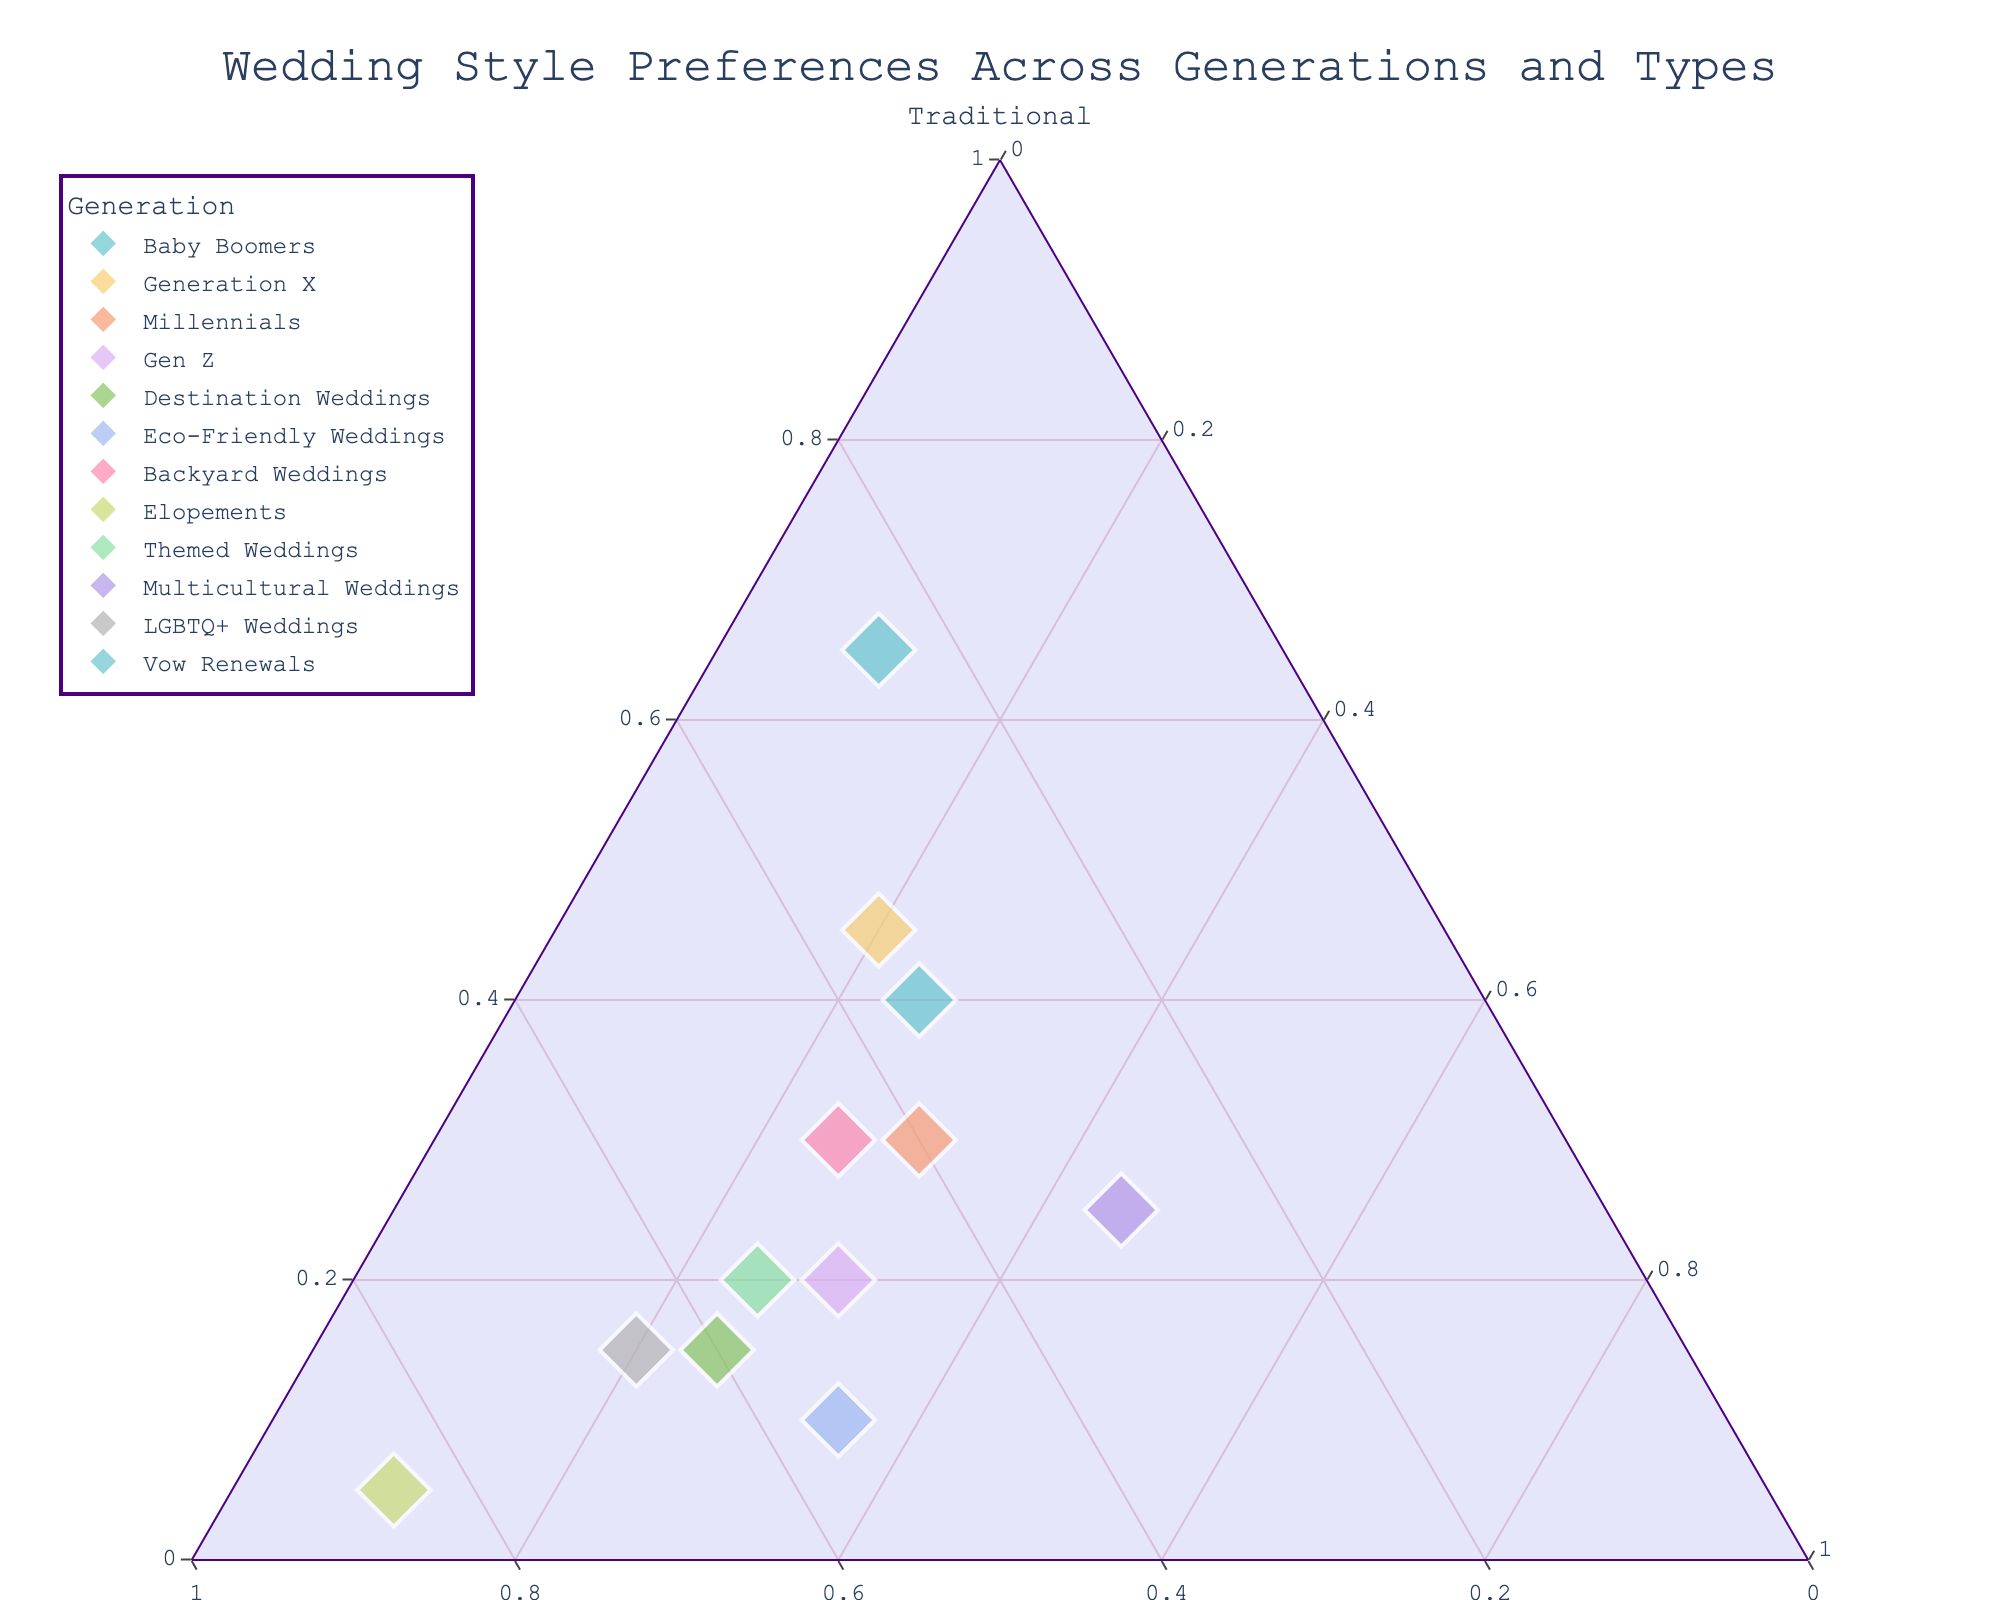Which generation has the highest preference for traditional weddings? The Baby Boomers segment has a data point positioned closest to the "Traditional" vertex of the triangle, indicating they have the highest percentage of preference for traditional weddings.
Answer: Baby Boomers Which type of wedding has the lowest preference for non-traditional weddings? The Elopements segment is closest to the "Non-Traditional" vertex, showing they have the highest non-traditional weddings preference and, therefore, the lowest percentage of traditional weddings preference.
Answer: Elopements How does the preference for fusion weddings compare between Millennials and Generation X? Millennials and Generation X both have their data points positioned equally distant from the 'Fusion' vertex; however, Millennials are closer, indicating that Millennials have a higher preference for fusion weddings than Generation X.
Answer: Millennials Which type of wedding shows the highest preference for non-traditional styles? The Elopements have their data point located closest to the "Non-Traditional" vertex, showing the highest preference for non-traditional weddings.
Answer: Elopements Among Baby Boomers, Millennials, and Gen Z, who has the highest preference for fusion weddings? The Gen Z group has their data point positioned closest to the "Fusion" vertex compared to Baby Boomers and Millennials, indicating the highest preference for fusion weddings.
Answer: Gen Z Compared to traditional weddings, how does Vow Renewals' preference shift towards non-traditional and fusion weddings? Vow Renewals is closer to the "Non-Traditional" and "Fusion" vertices than traditional ones. This indicates that preference shifts more towards non-traditional and fusion weddings.
Answer: More towards non-traditional and fusion What is common about the preferences for Eco-Friendly Weddings and Backyard Weddings? Both segments are located relatively closer to the "Non-Traditional" vertex, showing a strong preference for non-traditional weddings.
Answer: Strong non-traditional preference Is there any type of wedding that has an equal preference for fusion and traditional weddings? No data point lies on the line capturing equal distances between the "Fusion" and "Traditional" vertices, suggesting that no type has equal preference for both.
Answer: No Which generation has the most balanced preference between traditional, non-traditional, and fusion weddings? The Millennial group lies closest to the center, showing the most balanced preference between the three wedding styles.
Answer: Millennials How does the preference for traditional weddings change across generations from Baby Boomers to Gen Z? Baby Boomers are closest to the traditional vertex, scoring highest, followed by gradual decreases in traditional preference through Generation X, Millennials, and the lowest in Gen Z.
Answer: Decreases from Baby Boomers to Gen Z 